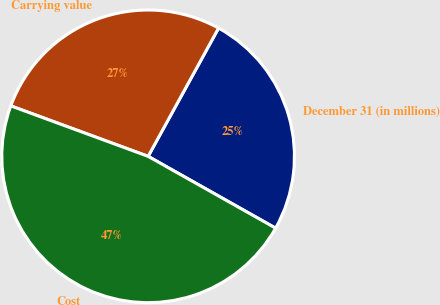<chart> <loc_0><loc_0><loc_500><loc_500><pie_chart><fcel>December 31 (in millions)<fcel>Carrying value<fcel>Cost<nl><fcel>25.17%<fcel>27.39%<fcel>47.44%<nl></chart> 